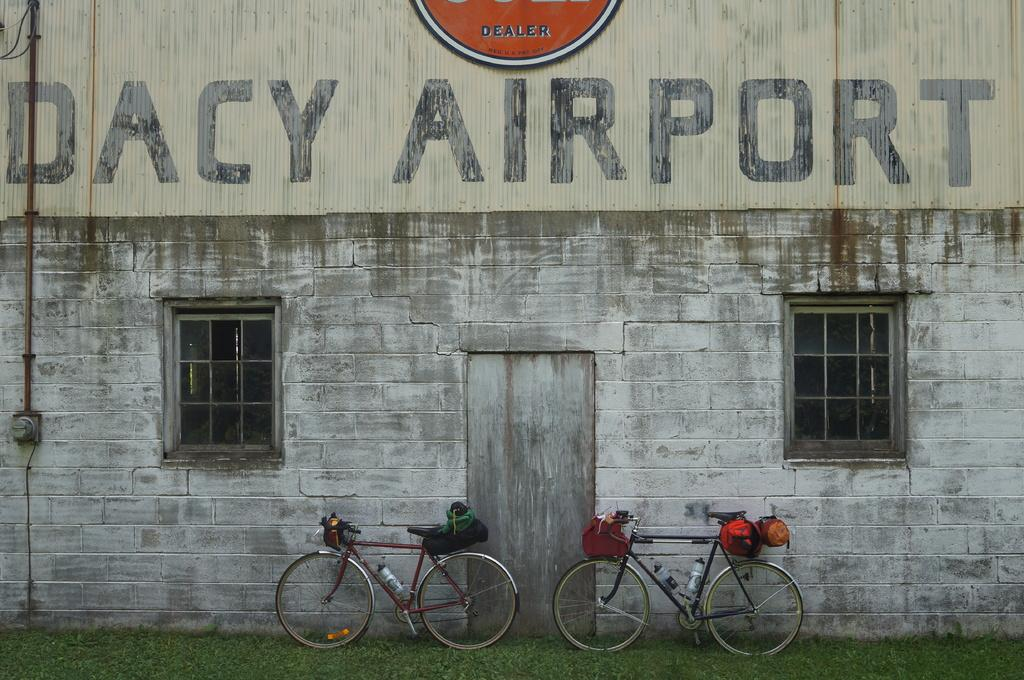What type of vehicles are in the image? There are bicycles in the image. Where are the bicycles located in relation to the wall? The bicycles are near a wall. What is the surface on which the bicycles are placed? The bicycles are on the grass. What is attached to the bicycles? There is baggage on the bicycles. What can be seen on the wall? There is a metal rod on the wall. What type of development can be seen taking place near the dock in the image? There is no dock or development present in the image; it features bicycles near a wall and on the grass. 